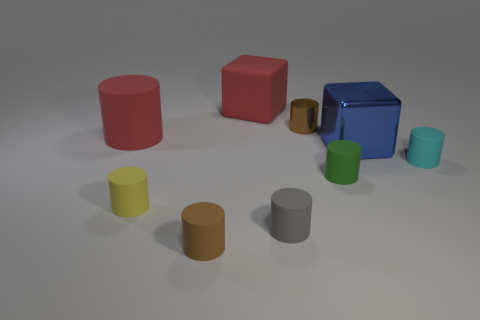How many other objects are there of the same material as the red block?
Make the answer very short. 6. Do the big red cylinder and the cube that is in front of the red matte cylinder have the same material?
Your answer should be compact. No. Are there fewer metal cylinders that are left of the gray object than green objects that are behind the cyan thing?
Provide a succinct answer. No. What color is the block that is behind the big blue cube?
Your answer should be compact. Red. How many other objects are the same color as the large rubber cylinder?
Your answer should be compact. 1. There is a brown thing that is behind the green object; is its size the same as the small cyan matte object?
Offer a terse response. Yes. There is a big blue cube; how many cyan rubber things are right of it?
Your response must be concise. 1. Are there any cyan things of the same size as the matte cube?
Give a very brief answer. No. Is the color of the shiny cylinder the same as the large shiny block?
Keep it short and to the point. No. What is the color of the rubber thing behind the brown cylinder that is behind the green rubber cylinder?
Your answer should be very brief. Red. 